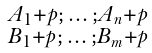<formula> <loc_0><loc_0><loc_500><loc_500>\begin{smallmatrix} A _ { 1 } + p ; \, \dots \, ; A _ { n } + p \\ B _ { 1 } + p ; \, \dots \, ; B _ { m } + p \end{smallmatrix}</formula> 